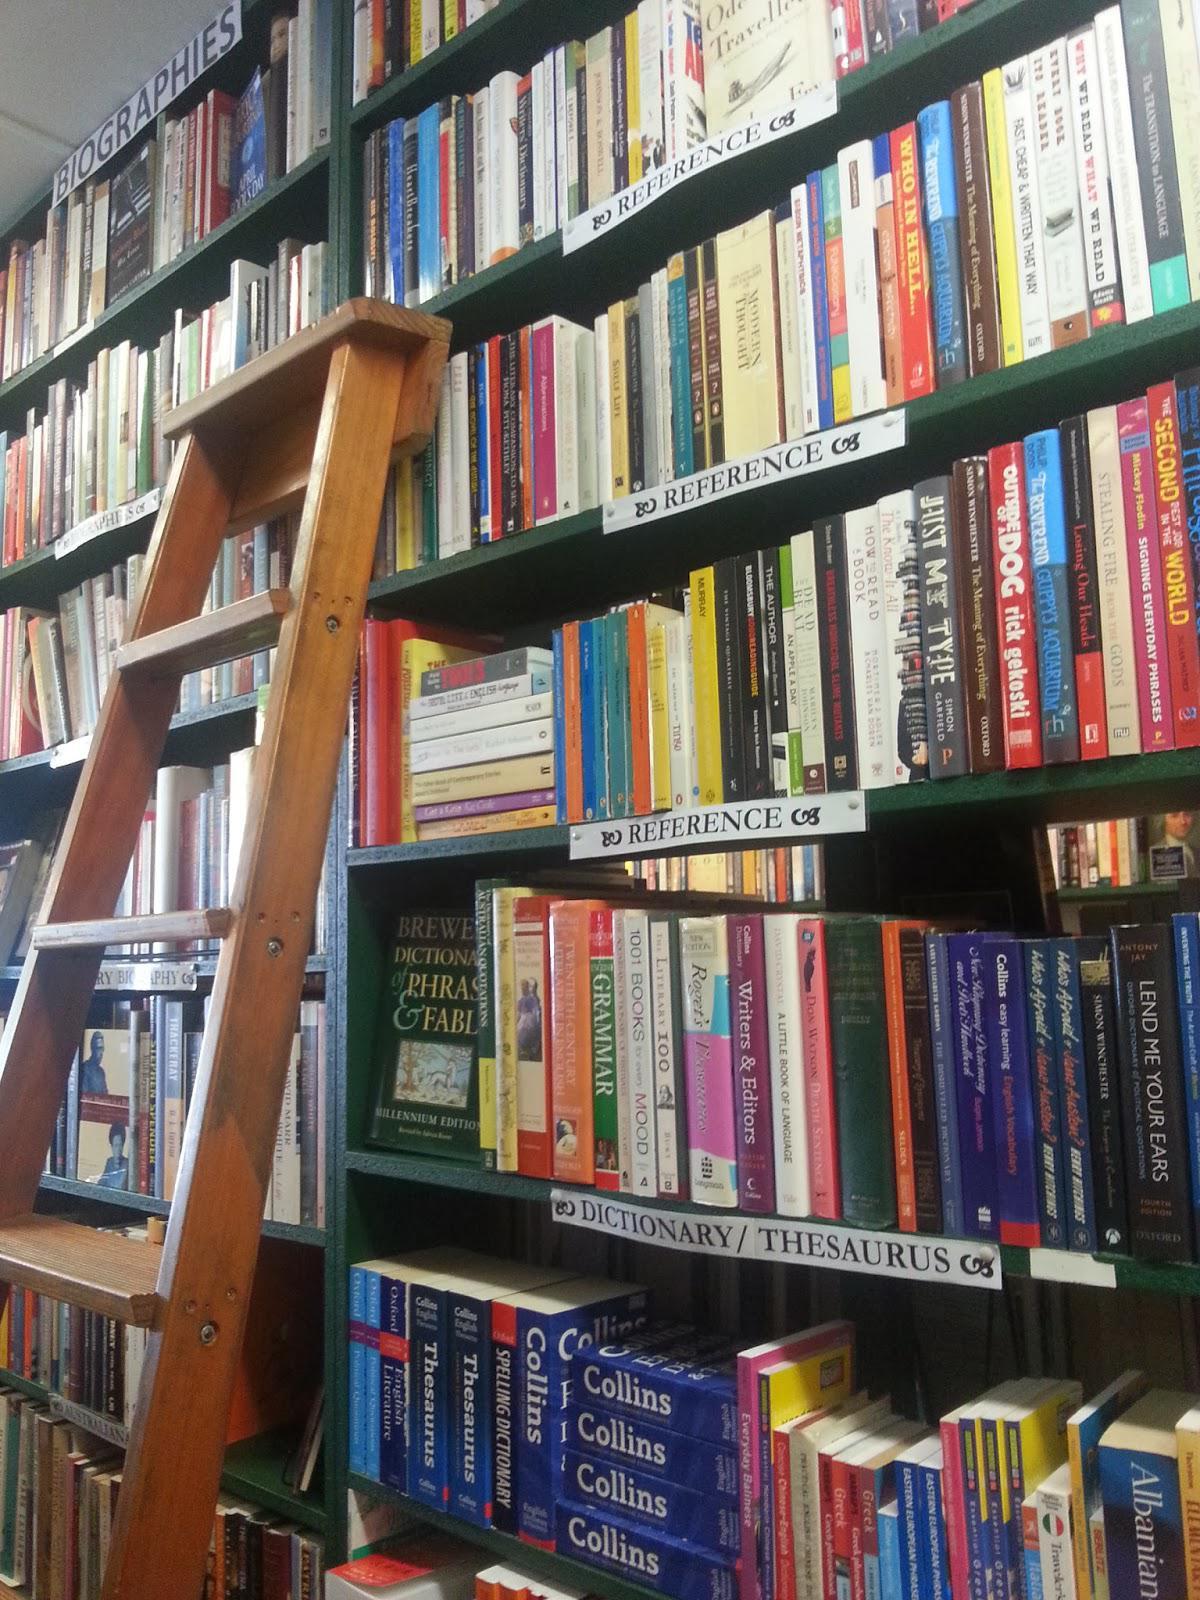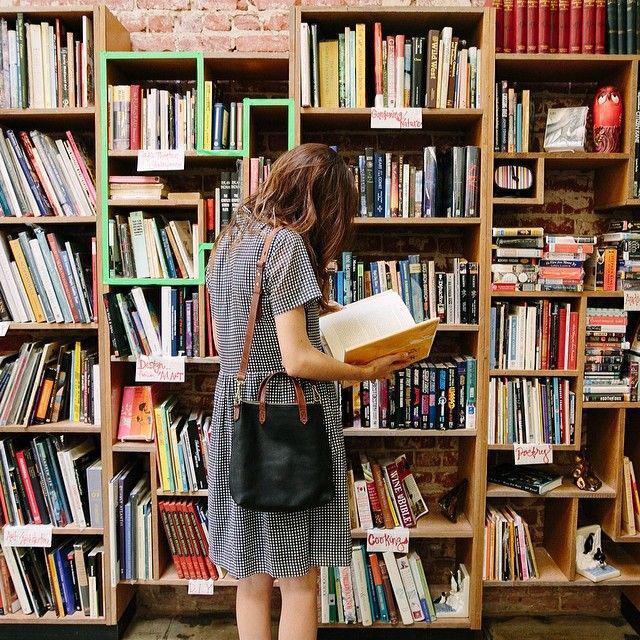The first image is the image on the left, the second image is the image on the right. For the images displayed, is the sentence "The right image shows no more than six shelves of books and no shelves have white labels on their edges." factually correct? Answer yes or no. No. 